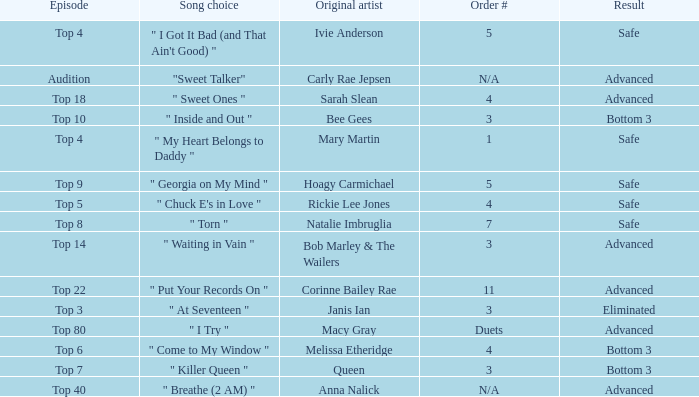What's the order number of the song originally performed by Rickie Lee Jones? 4.0. Can you parse all the data within this table? {'header': ['Episode', 'Song choice', 'Original artist', 'Order #', 'Result'], 'rows': [['Top 4', '" I Got It Bad (and That Ain\'t Good) "', 'Ivie Anderson', '5', 'Safe'], ['Audition', '"Sweet Talker"', 'Carly Rae Jepsen', 'N/A', 'Advanced'], ['Top 18', '" Sweet Ones "', 'Sarah Slean', '4', 'Advanced'], ['Top 10', '" Inside and Out "', 'Bee Gees', '3', 'Bottom 3'], ['Top 4', '" My Heart Belongs to Daddy "', 'Mary Martin', '1', 'Safe'], ['Top 9', '" Georgia on My Mind "', 'Hoagy Carmichael', '5', 'Safe'], ['Top 5', '" Chuck E\'s in Love "', 'Rickie Lee Jones', '4', 'Safe'], ['Top 8', '" Torn "', 'Natalie Imbruglia', '7', 'Safe'], ['Top 14', '" Waiting in Vain "', 'Bob Marley & The Wailers', '3', 'Advanced'], ['Top 22', '" Put Your Records On "', 'Corinne Bailey Rae', '11', 'Advanced'], ['Top 3', '" At Seventeen "', 'Janis Ian', '3', 'Eliminated'], ['Top 80', '" I Try "', 'Macy Gray', 'Duets', 'Advanced'], ['Top 6', '" Come to My Window "', 'Melissa Etheridge', '4', 'Bottom 3'], ['Top 7', '" Killer Queen "', 'Queen', '3', 'Bottom 3'], ['Top 40', '" Breathe (2 AM) "', 'Anna Nalick', 'N/A', 'Advanced']]} 